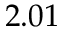Convert formula to latex. <formula><loc_0><loc_0><loc_500><loc_500>2 . 0 1</formula> 